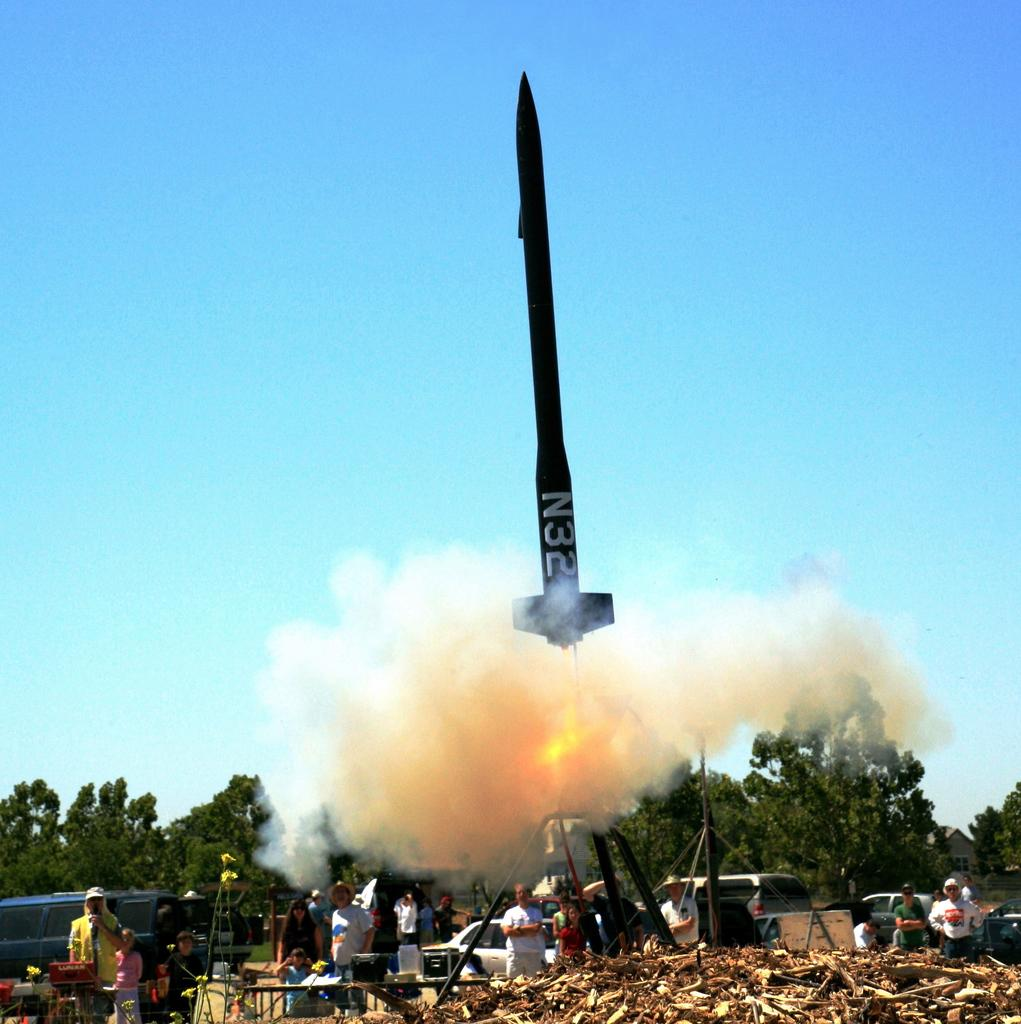What is the main subject of the image? There is a rocket in the image. What can be seen around the rocket? There is smoke in the image. What type of natural elements are present in the image? There are trees in the image. What else can be seen in the image besides the rocket and trees? There are vehicles, people, and a table in the image. What is visible in the background of the image? The sky is visible in the image. How many giraffes can be seen interacting with the rocket in the image? There are no giraffes present in the image; it features a rocket, smoke, trees, vehicles, people, and a table. What type of friction is being generated by the rocket in the image? The image does not provide information about the type of friction being generated by the rocket. 